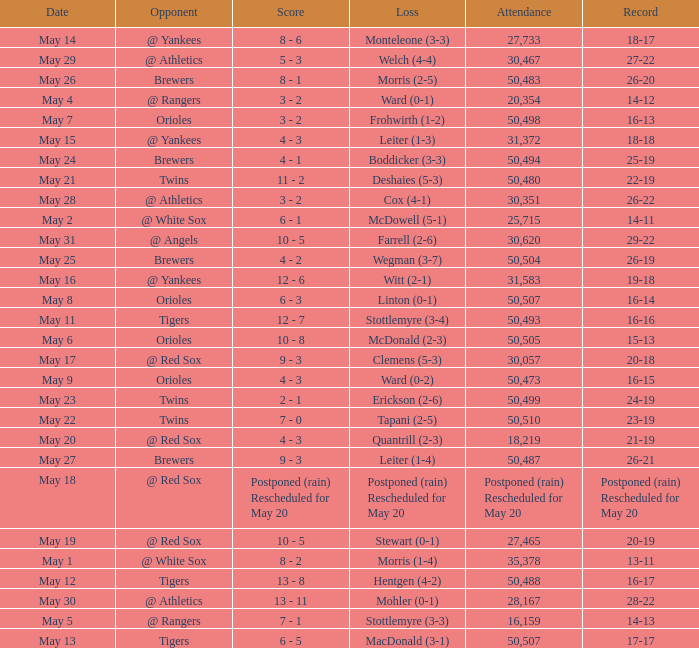On May 29 which team had the loss? Welch (4-4). 